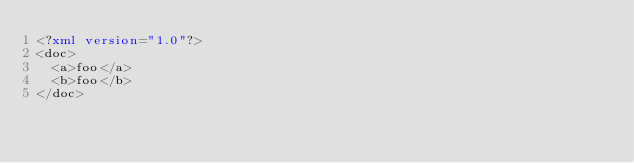<code> <loc_0><loc_0><loc_500><loc_500><_XML_><?xml version="1.0"?> 
<doc>
  <a>foo</a>
  <b>foo</b>
</doc></code> 